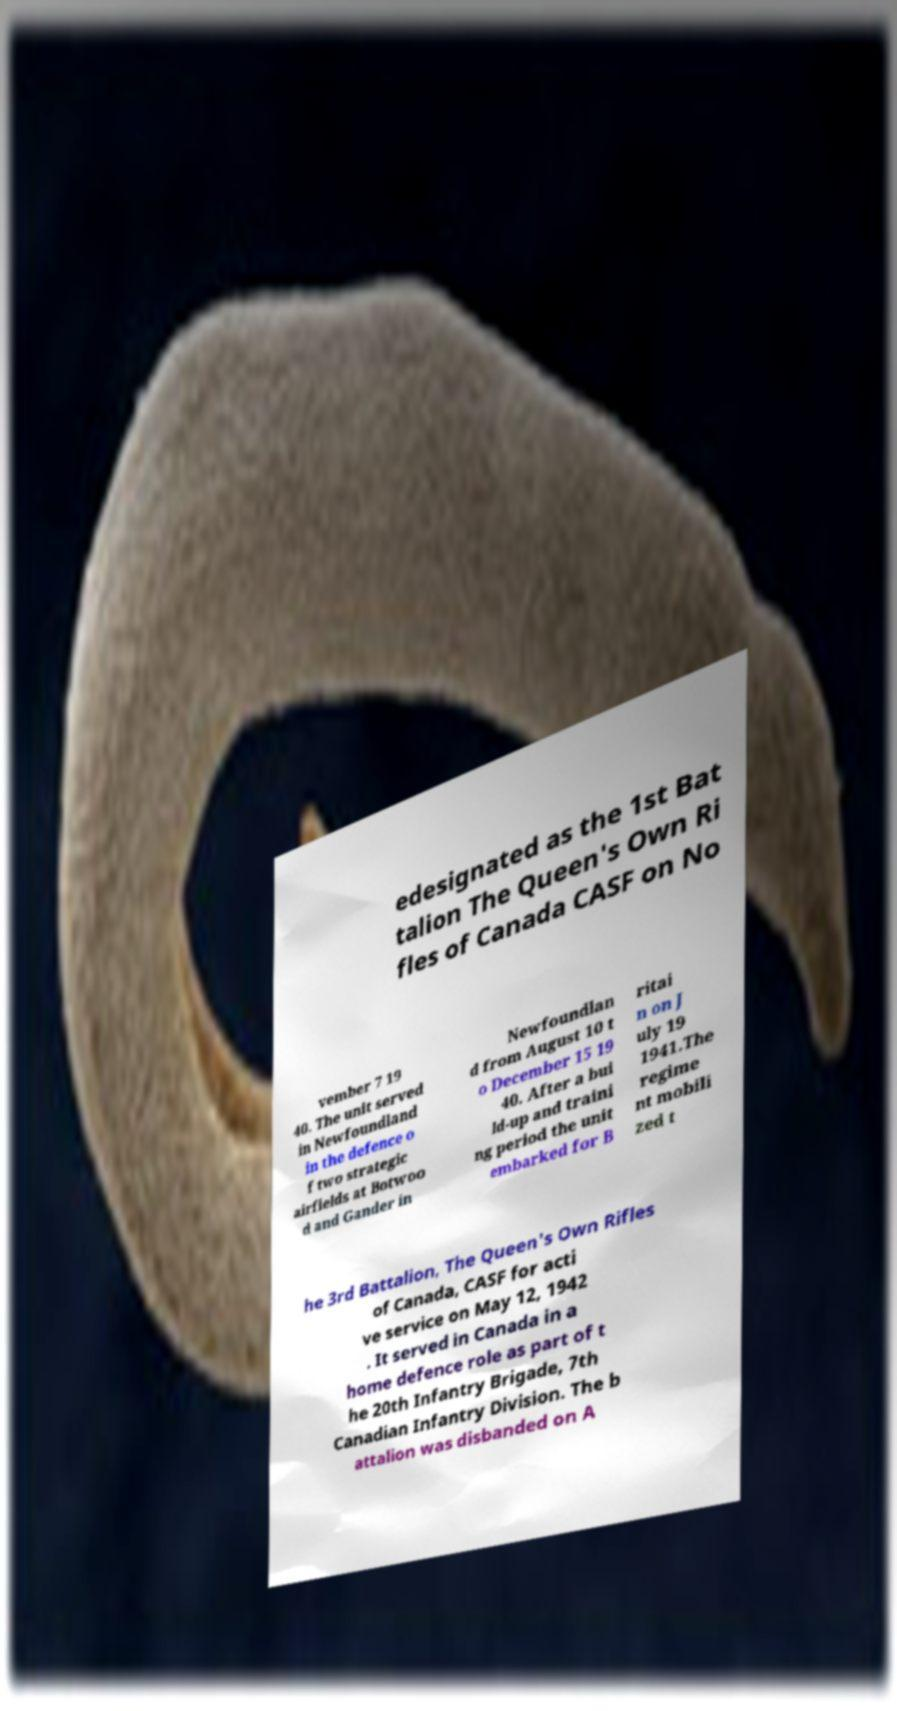What messages or text are displayed in this image? I need them in a readable, typed format. edesignated as the 1st Bat talion The Queen's Own Ri fles of Canada CASF on No vember 7 19 40. The unit served in Newfoundland in the defence o f two strategic airfields at Botwoo d and Gander in Newfoundlan d from August 10 t o December 15 19 40. After a bui ld-up and traini ng period the unit embarked for B ritai n on J uly 19 1941.The regime nt mobili zed t he 3rd Battalion, The Queen's Own Rifles of Canada, CASF for acti ve service on May 12, 1942 . It served in Canada in a home defence role as part of t he 20th Infantry Brigade, 7th Canadian Infantry Division. The b attalion was disbanded on A 